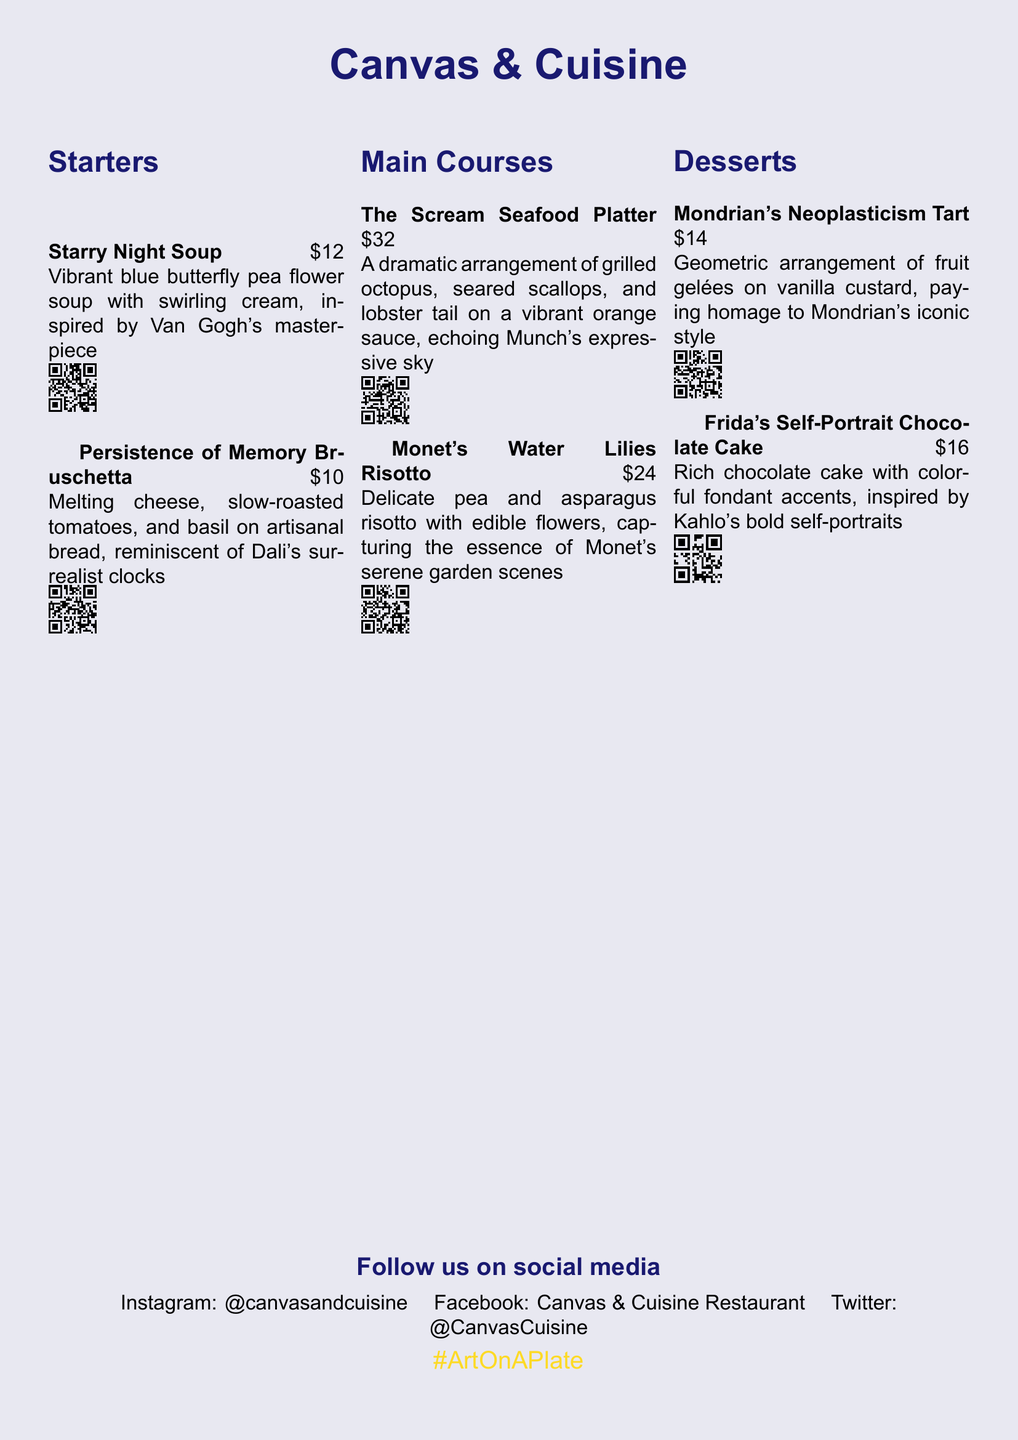What is the name of the first starter? The first starter listed in the menu is "Starry Night Soup."
Answer: Starry Night Soup How much does the Persistence of Memory Bruschetta cost? The menu states that the cost of the Persistence of Memory Bruschetta is $10.
Answer: $10 What dish is inspired by Frida Kahlo? According to the menu, the dessert inspired by Frida Kahlo is "Frida's Self-Portrait Chocolate Cake."
Answer: Frida's Self-Portrait Chocolate Cake Which main course features seafood? The main course that features seafood is "The Scream Seafood Platter."
Answer: The Scream Seafood Platter How many main courses are listed on the menu? The menu indicates that there are two main courses mentioned, which are The Scream Seafood Platter and Monet's Water Lilies Risotto.
Answer: 2 What is the color scheme for the restaurant name? The color scheme for the restaurant's name blends blue hues, as indicated by the color theme used in the document.
Answer: starryblue Which dish has a vibrant orange sauce? The dish with a vibrant orange sauce is "The Scream Seafood Platter," as described in the document.
Answer: The Scream Seafood Platter What is the Instagram handle for this restaurant? The menu provides the Instagram handle as @canvasandcuisine.
Answer: @canvasandcuisine How does the menu visually represent its theme? The menu creatively represents its theme through artistically plated dishes inspired by famous paintings, as noted in the heading.
Answer: Artistically plated dishes 